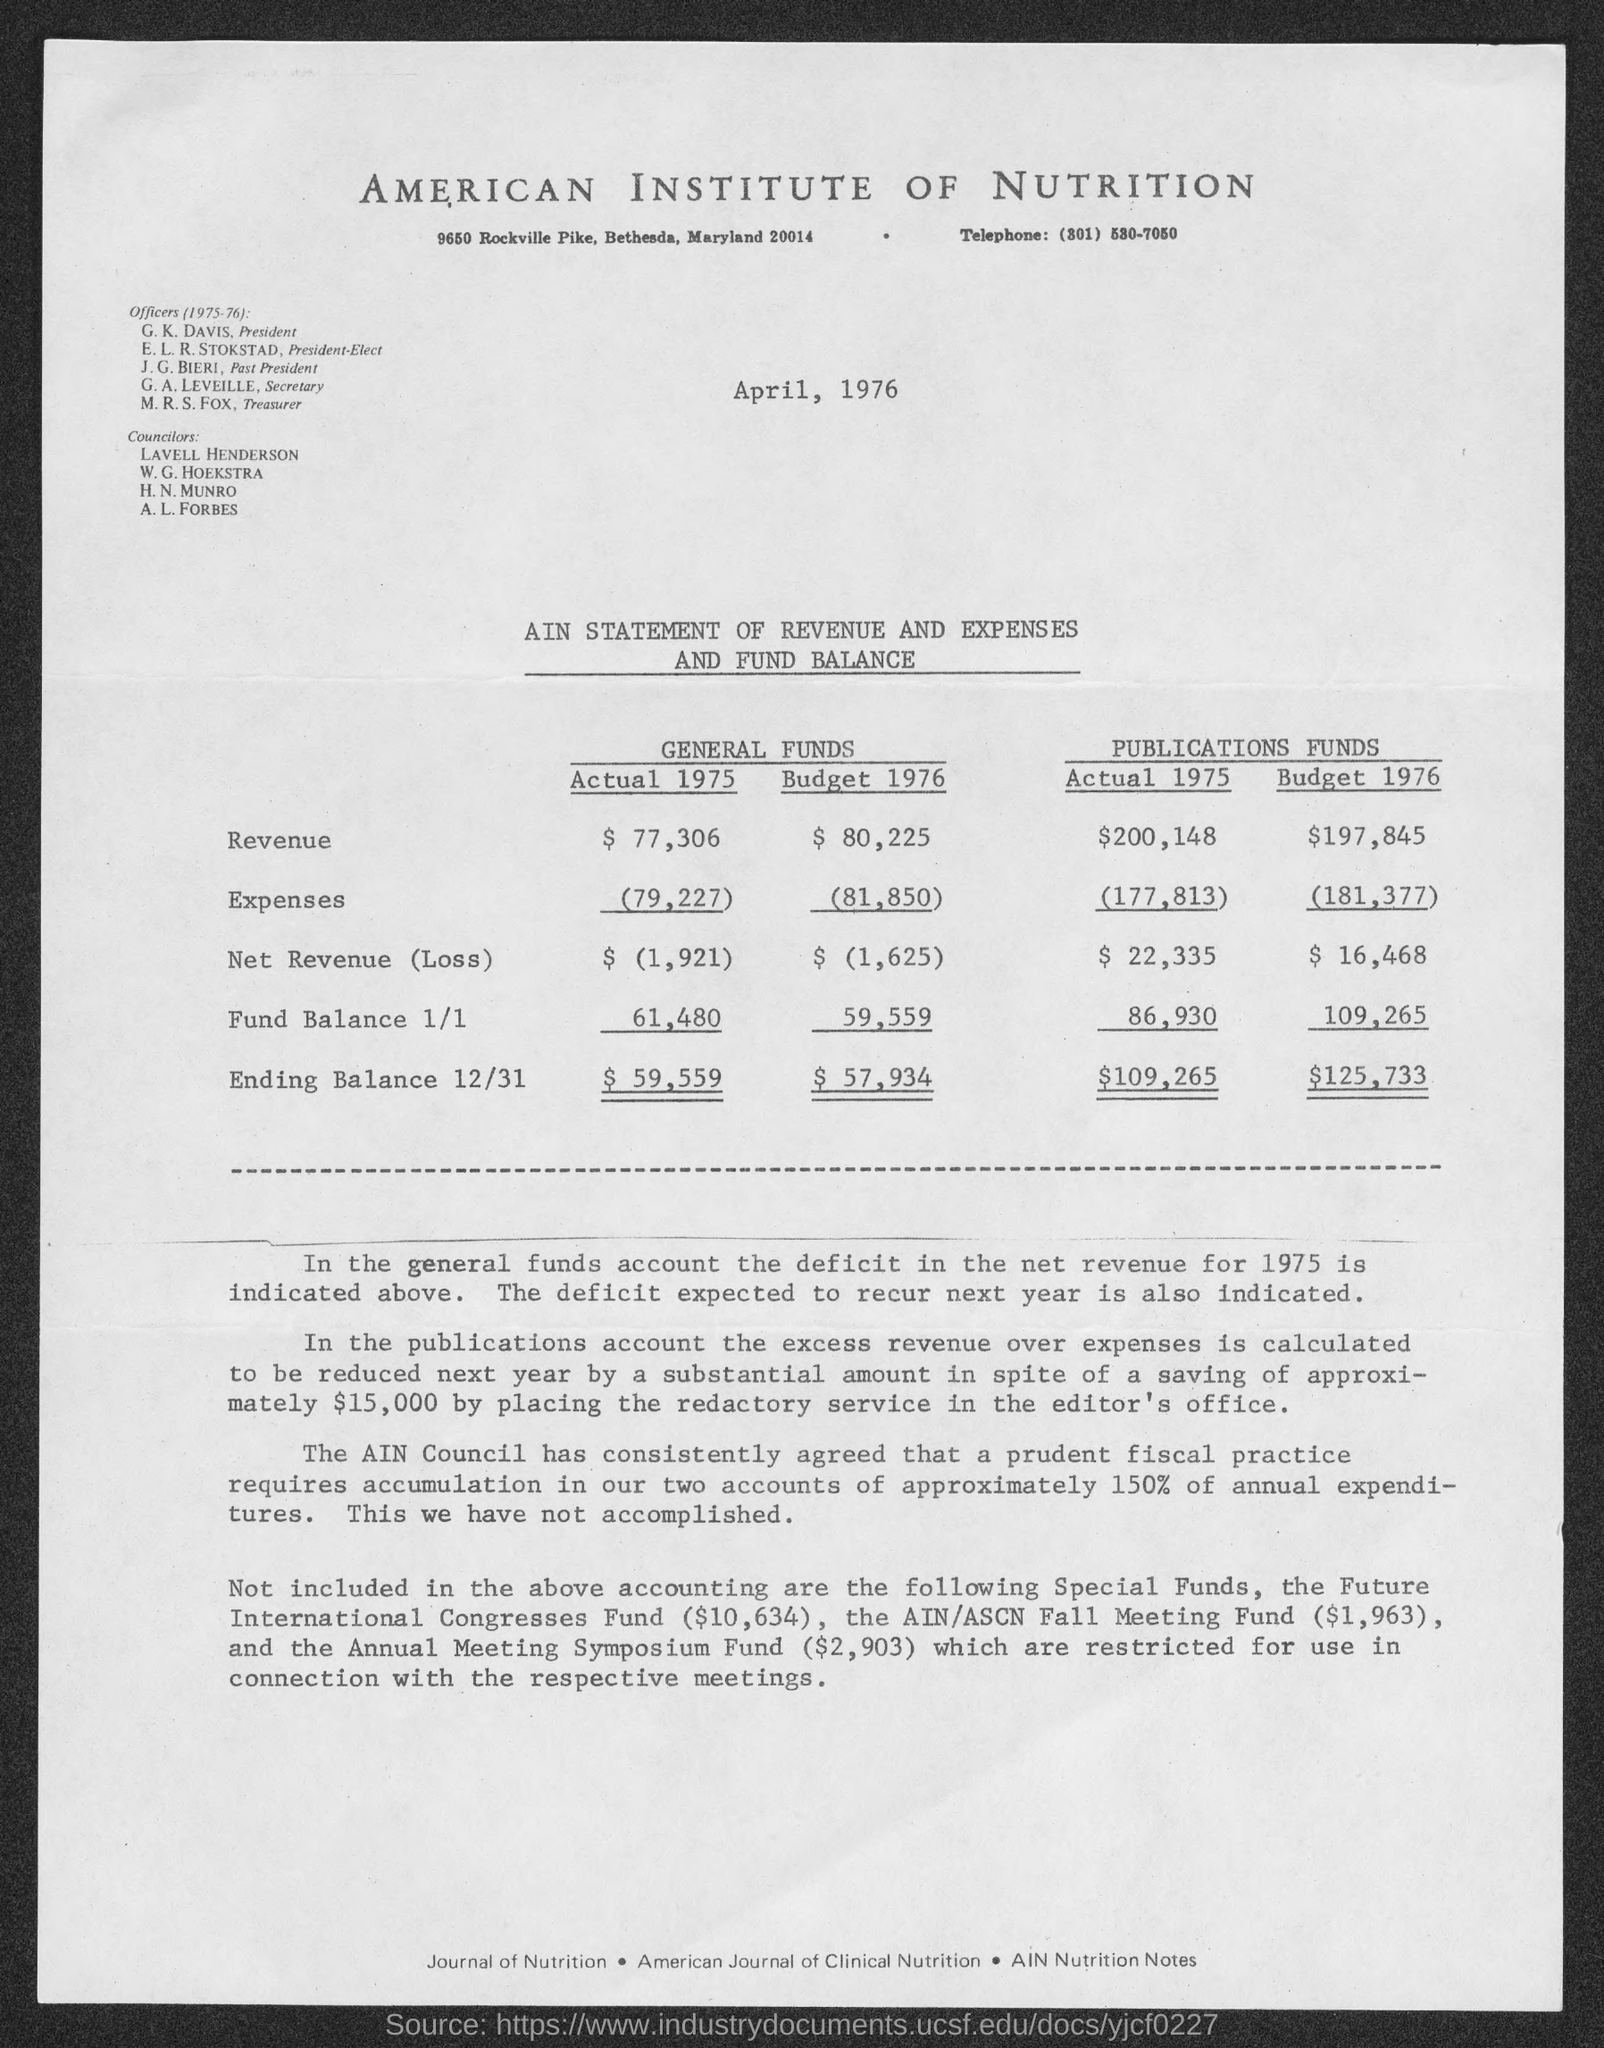Mention a couple of crucial points in this snapshot. The document mentions that April 1976 is the date. The document in question is titled "American Institute of Nutrition. 